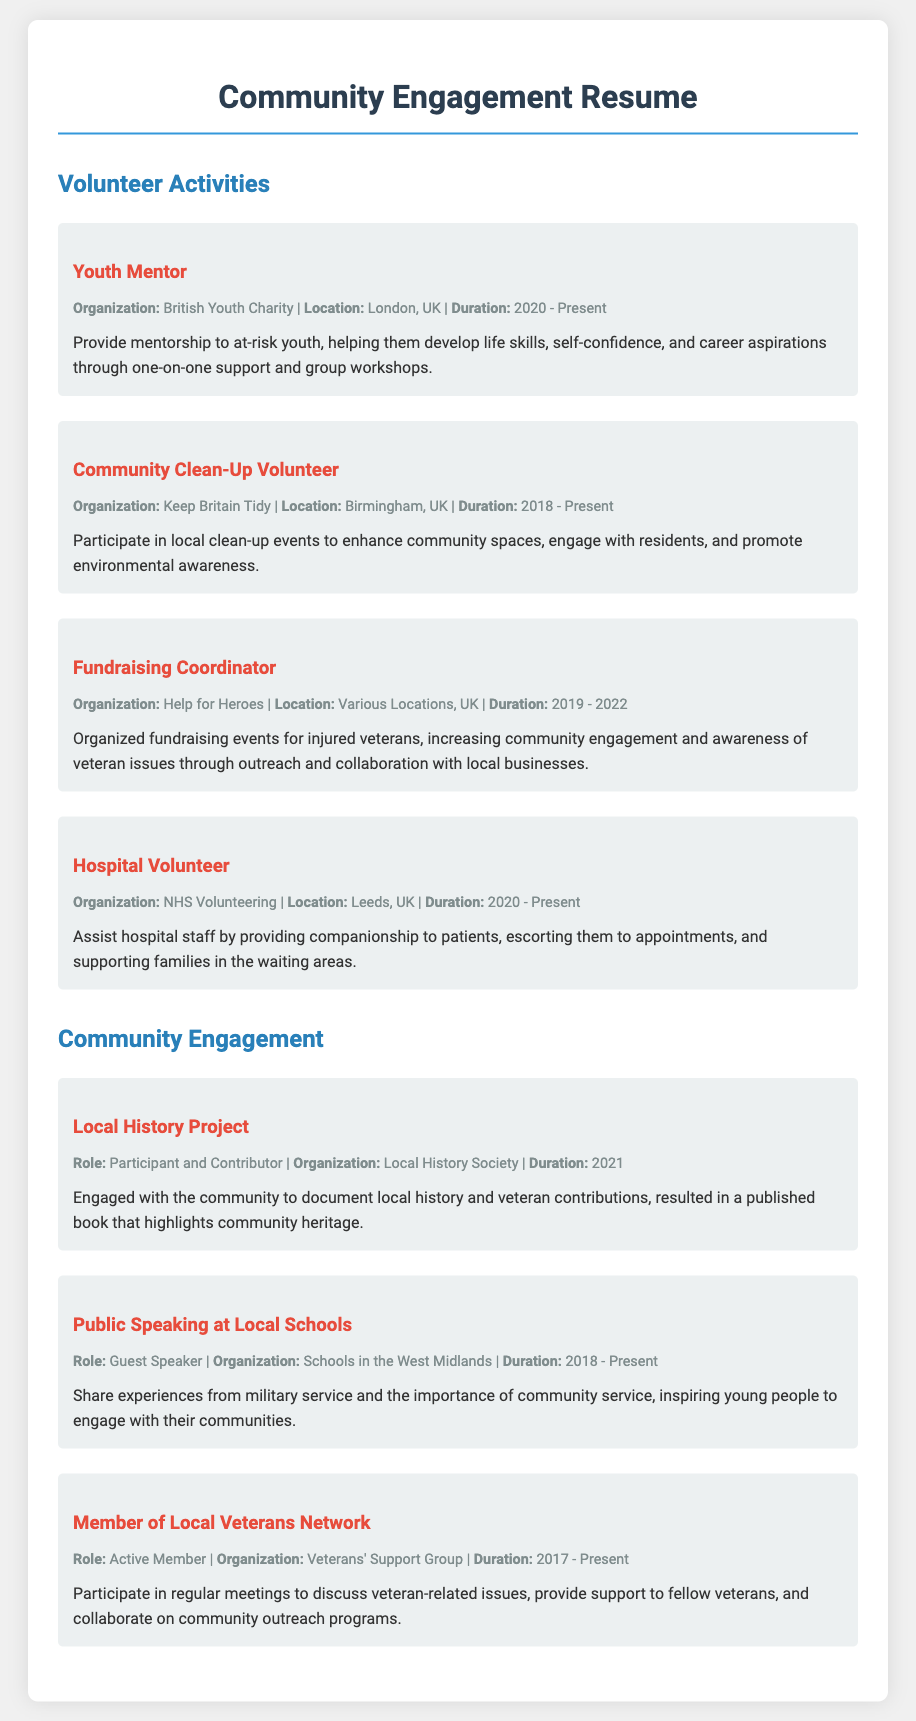What is the role of the person in the Youth Mentor activity? The role is to provide mentorship to at-risk youth.
Answer: Mentorship What is the organization associated with the Community Clean-Up Volunteer? The organization is named Keep Britain Tidy.
Answer: Keep Britain Tidy What year did the Fundraising Coordinator activity start? The activity started in the year 2019.
Answer: 2019 How long has the person been volunteering as a Hospital Volunteer? The duration is from 2020 to present, indicating multiple years.
Answer: 3 years What type of project did the person participate in for the Local History Project? The type of project engaged the community in documenting local history.
Answer: Documenting local history How many years has the person been an active member of the Local Veterans Network? The person has been an active member since 2017, making it a duration of several years until now.
Answer: 6 years What is the main purpose of the public speaking engagements at local schools? The main purpose is to inspire young people to engage with their communities.
Answer: Inspire engagement Which organization did the person work with to raise awareness of veteran issues? The organization is Help for Heroes.
Answer: Help for Heroes During which year was the Local History Project completed? The project was completed in the year 2021.
Answer: 2021 